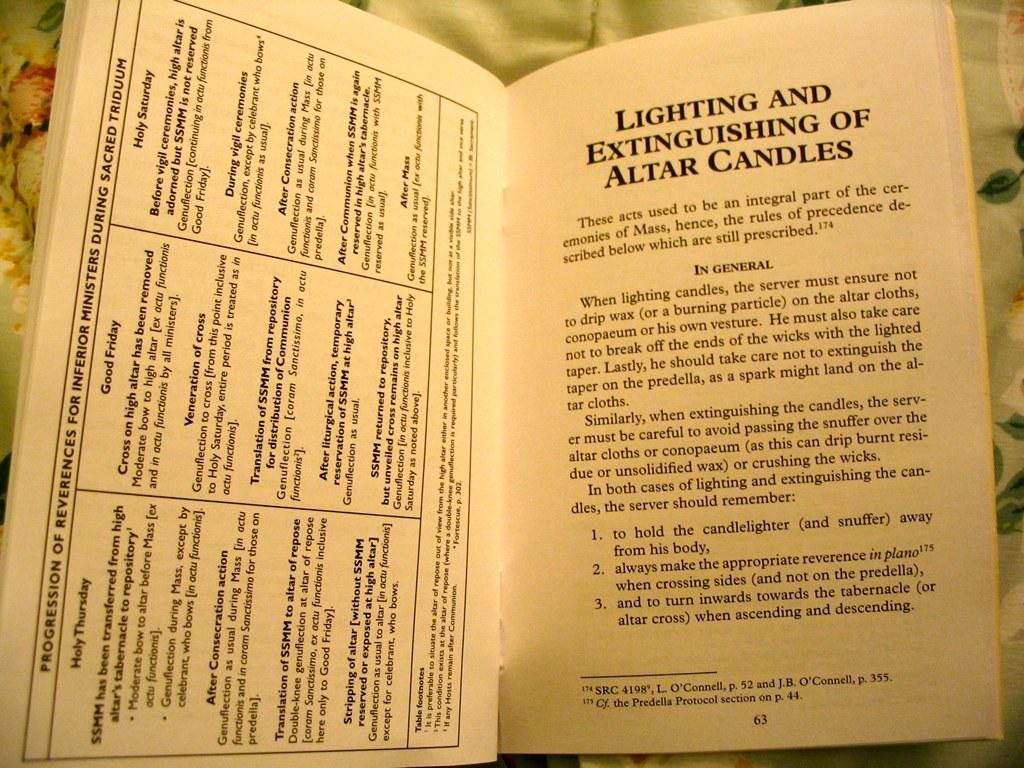<image>
Summarize the visual content of the image. A booklet is open to a page about lighting and extinguishing altar candles. 